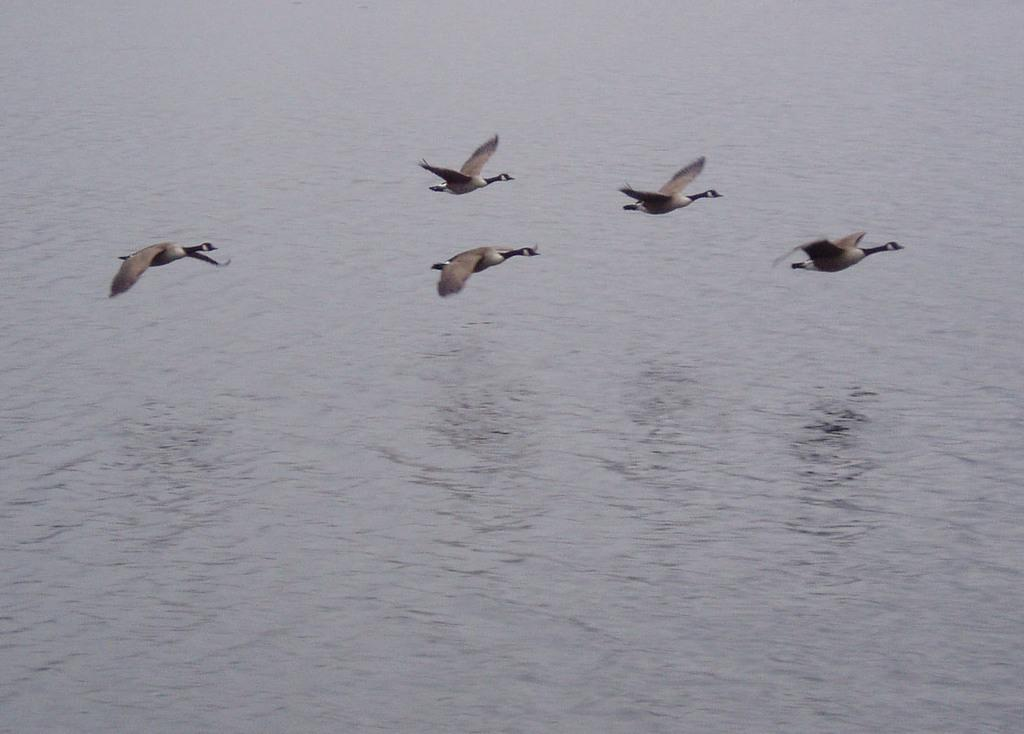How many birds can be seen in the image? There are five birds flying in the air in the image. What is visible in the image besides the birds? There is water visible in the image. What type of base can be seen supporting the cow in the image? There is no cow present in the image, so there is no base supporting a cow. 